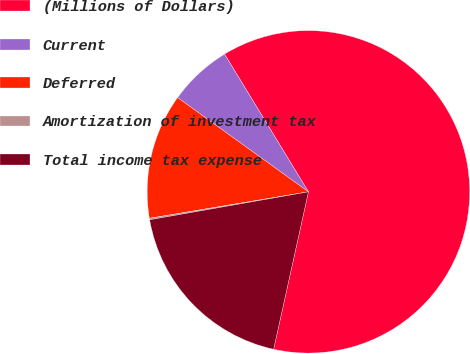Convert chart to OTSL. <chart><loc_0><loc_0><loc_500><loc_500><pie_chart><fcel>(Millions of Dollars)<fcel>Current<fcel>Deferred<fcel>Amortization of investment tax<fcel>Total income tax expense<nl><fcel>62.17%<fcel>6.36%<fcel>12.56%<fcel>0.15%<fcel>18.76%<nl></chart> 